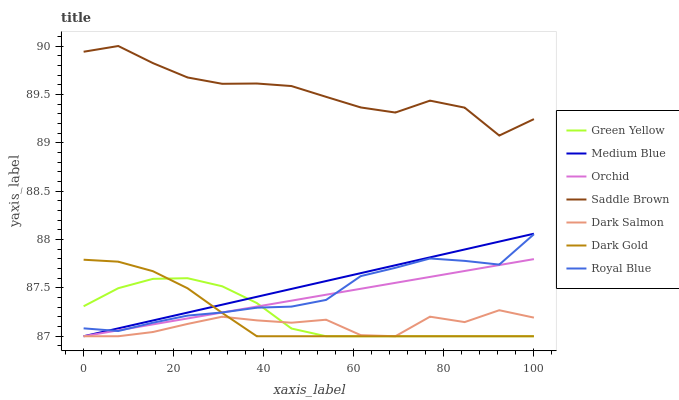Does Medium Blue have the minimum area under the curve?
Answer yes or no. No. Does Medium Blue have the maximum area under the curve?
Answer yes or no. No. Is Medium Blue the smoothest?
Answer yes or no. No. Is Medium Blue the roughest?
Answer yes or no. No. Does Royal Blue have the lowest value?
Answer yes or no. No. Does Medium Blue have the highest value?
Answer yes or no. No. Is Medium Blue less than Saddle Brown?
Answer yes or no. Yes. Is Saddle Brown greater than Medium Blue?
Answer yes or no. Yes. Does Medium Blue intersect Saddle Brown?
Answer yes or no. No. 